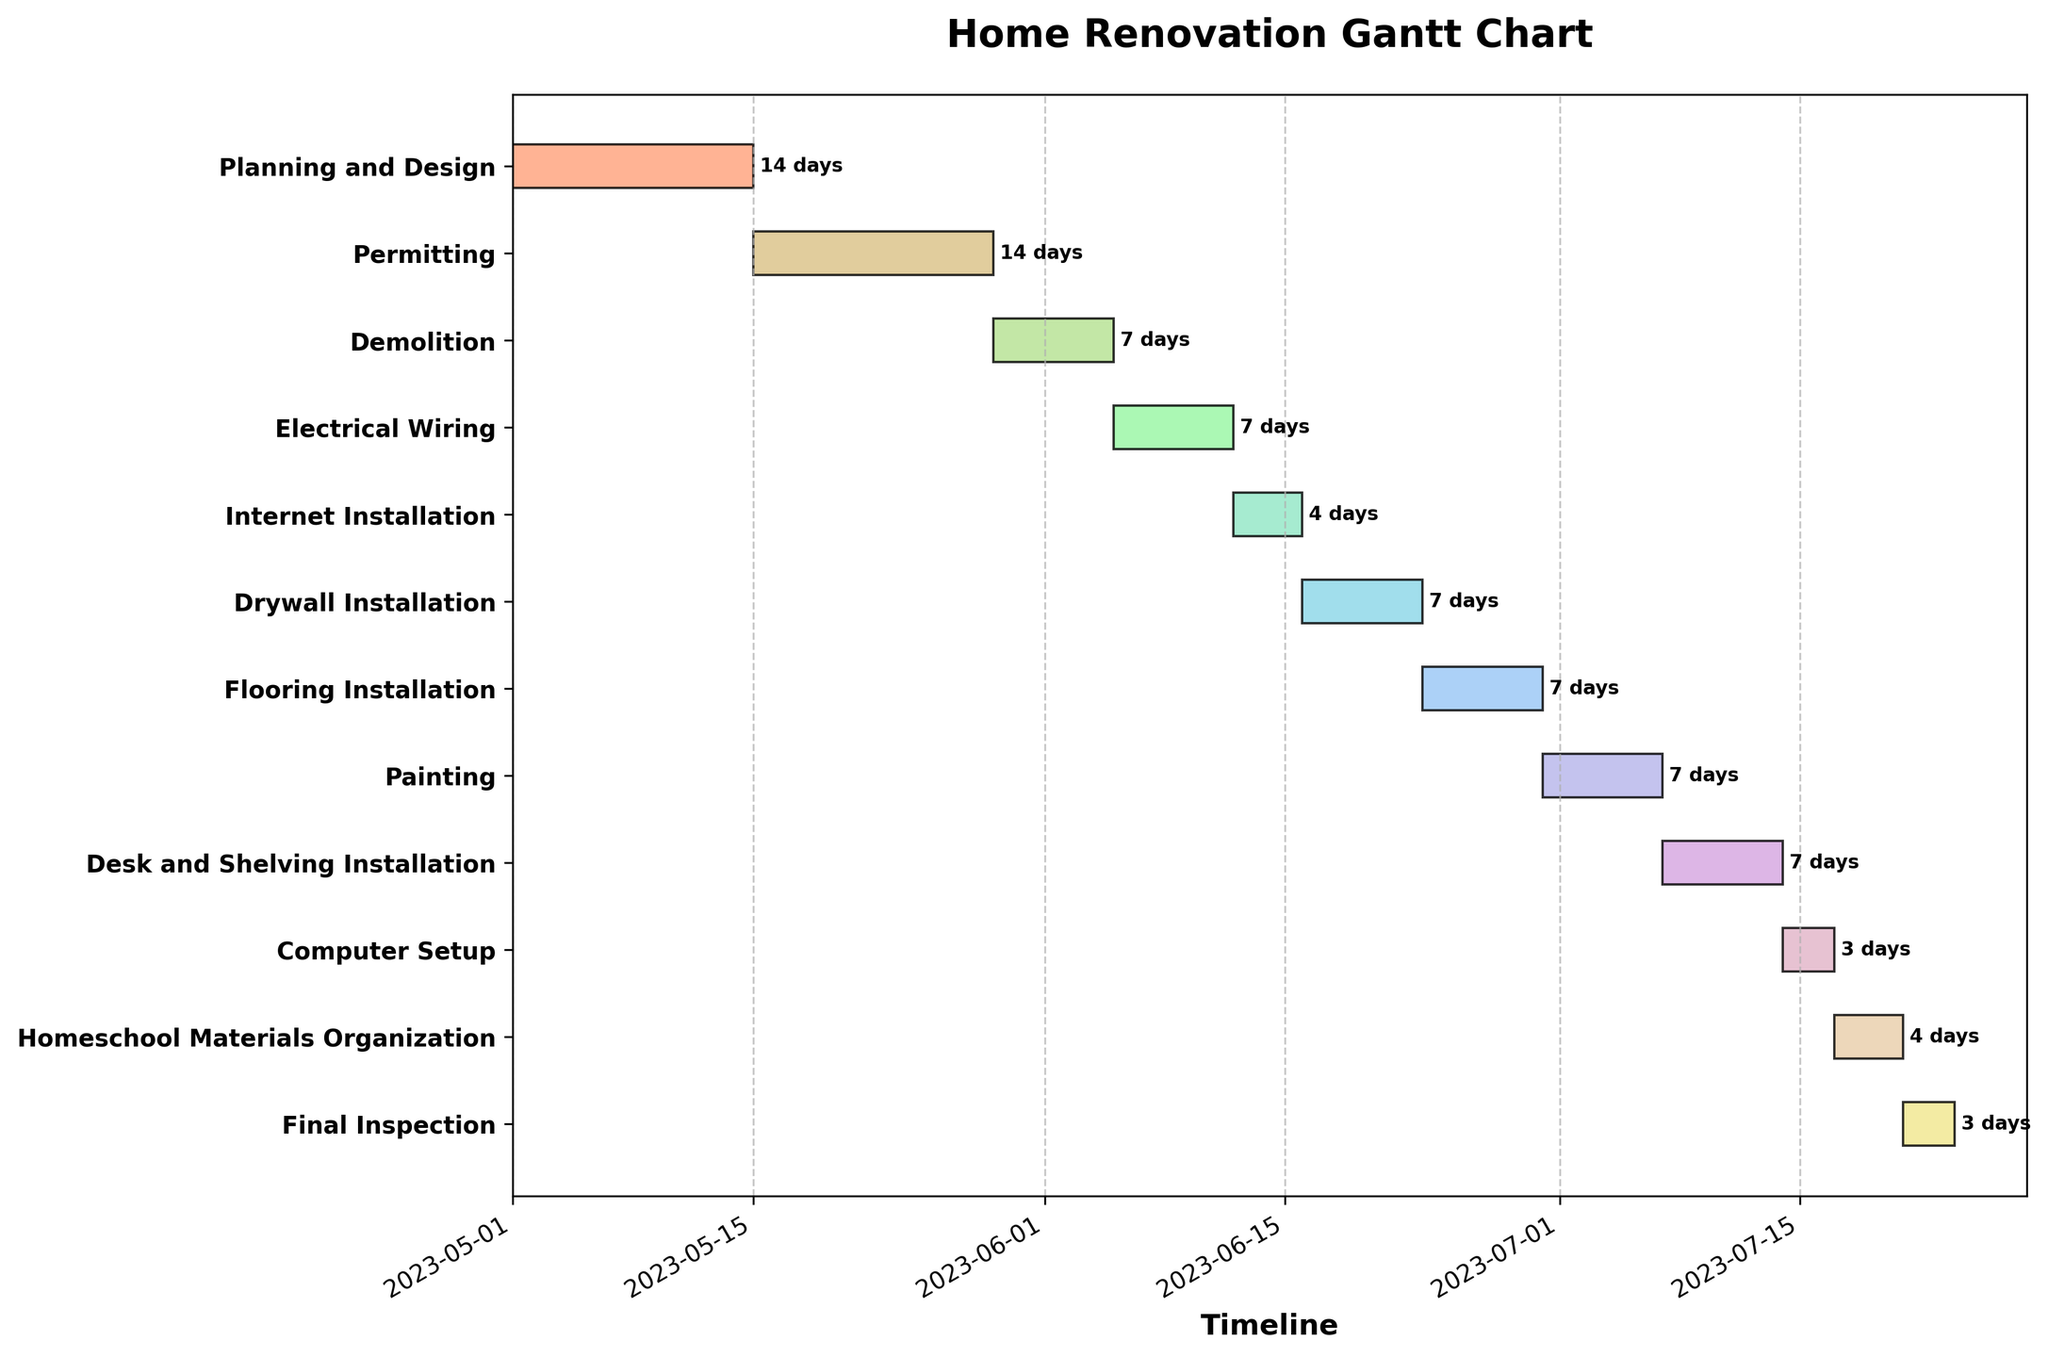What is the total duration of the "Planning and Design" phase? The duration of the "Planning and Design" phase can be directly read from the figure, which is 14 days.
Answer: 14 days How many phases have a duration of exactly 7 days? Check all the bars marked on the Gantt chart that indicate a duration of 7 days. There are "Demolition", "Electrical Wiring", "Drywall Installation", "Flooring Installation", "Painting", and "Desk and Shelving Installation". Count them.
Answer: 6 What is the longest phase in the home renovation project? Identify the longest bar in the Gantt chart. The "Planning and Design" and "Permitting" phases both last for 14 days, which is the longest duration.
Answer: Planning and Design & Permitting What is the total duration of all the renovation phases combined? Sum the duration of all the phases listed: 14 + 14 + 7 + 7 + 4 + 7 + 7 + 7 + 7 + 3 + 4 + 3.
Answer: 84 days Which phase immediately precedes the "Internet Installation" phase? Look at the bar just before the "Internet Installation" bar on the Gantt chart. The phase that ends right before its start date is "Electrical Wiring".
Answer: Electrical Wiring Which phases overlap in their timelines? Examine the Gantt chart bars to see which bars overlap horizontally. Phases without gaps between them don't overlap. None of the phases overlap since all start after the previous one ends.
Answer: None When does the "Flooring Installation" phase start and end? Refer to the start and end dates provided for the "Flooring Installation" phase. It starts on 2023-06-23 and ends on 2023-06-29.
Answer: 2023-06-23 to 2023-06-29 Which two phases have the shortest duration? Compare the duration of all the phases using the Gantt chart. The "Computer Setup" and "Final Inspection" phases are the shortest, each lasting 3 days.
Answer: Computer Setup & Final Inspection What is the end date for the entire home renovation project? Look at the end date of the last phase, which is "Final Inspection". The end date is 2023-07-23.
Answer: 2023-07-23 